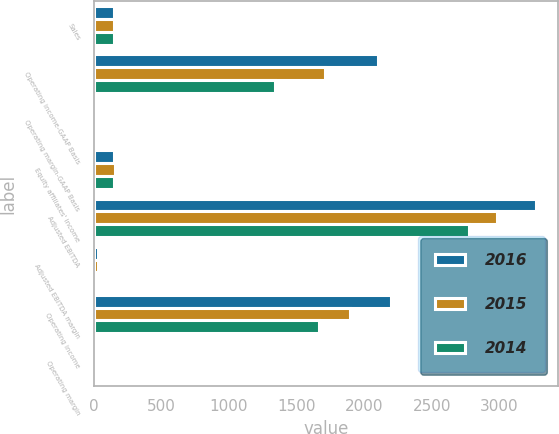Convert chart. <chart><loc_0><loc_0><loc_500><loc_500><stacked_bar_chart><ecel><fcel>Sales<fcel>Operating income-GAAP Basis<fcel>Operating margin-GAAP Basis<fcel>Equity affiliates' income<fcel>Adjusted EBITDA<fcel>Adjusted EBITDA margin<fcel>Operating income<fcel>Operating margin<nl><fcel>2016<fcel>151.4<fcel>2106<fcel>22.1<fcel>148.6<fcel>3273<fcel>34.4<fcel>2198.5<fcel>23.1<nl><fcel>2015<fcel>151.4<fcel>1708.3<fcel>17.3<fcel>154.5<fcel>2984.1<fcel>30.2<fcel>1893.2<fcel>19.1<nl><fcel>2014<fcel>151.4<fcel>1339.1<fcel>12.8<fcel>151.4<fcel>2775.7<fcel>26.6<fcel>1667.4<fcel>16<nl></chart> 